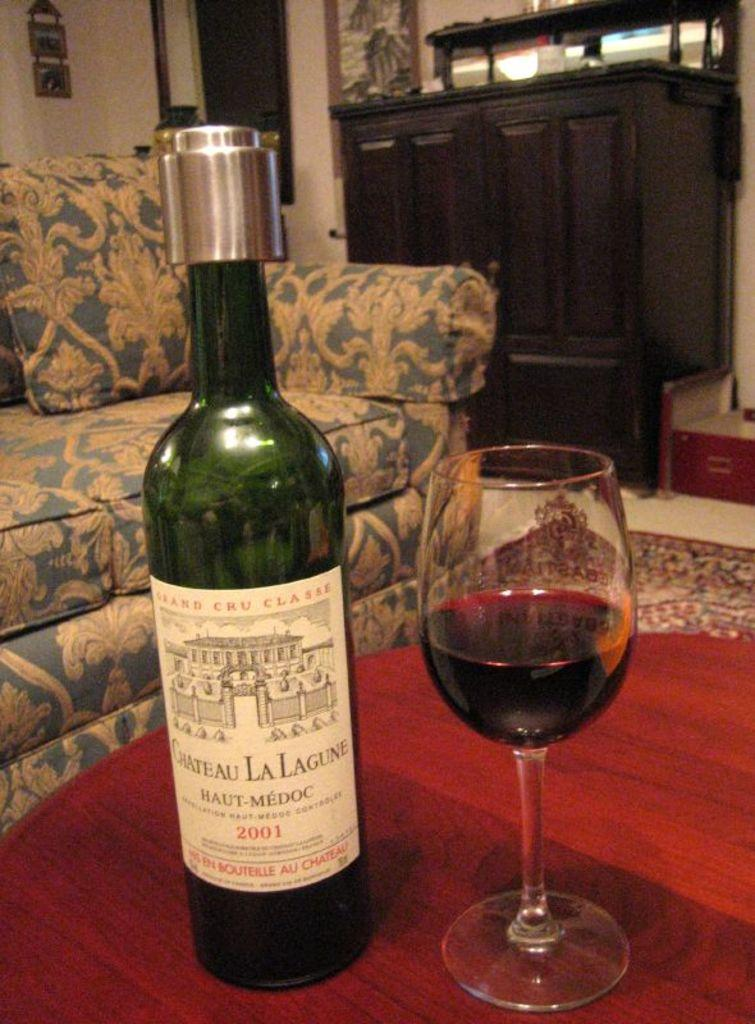<image>
Render a clear and concise summary of the photo. A bottle of Chateau La Lagune sits on a table next to a glass of wine. 